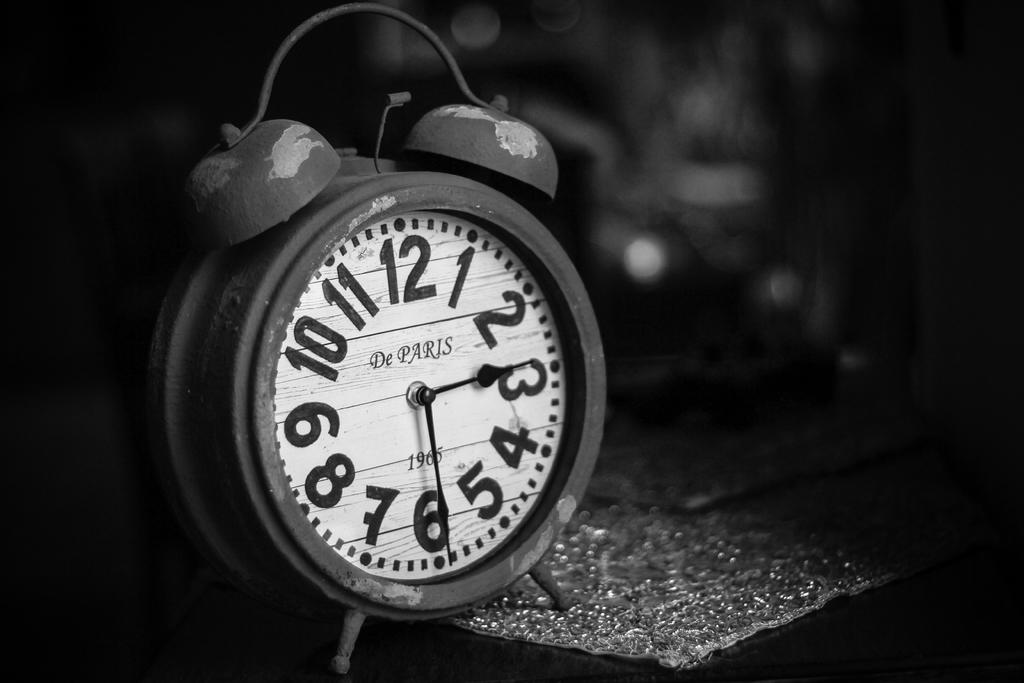<image>
Present a compact description of the photo's key features. An alarm clock is on a wet table and it says De Paris on the face. 